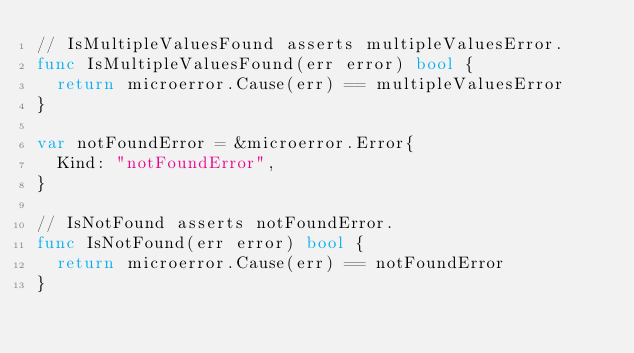Convert code to text. <code><loc_0><loc_0><loc_500><loc_500><_Go_>// IsMultipleValuesFound asserts multipleValuesError.
func IsMultipleValuesFound(err error) bool {
	return microerror.Cause(err) == multipleValuesError
}

var notFoundError = &microerror.Error{
	Kind: "notFoundError",
}

// IsNotFound asserts notFoundError.
func IsNotFound(err error) bool {
	return microerror.Cause(err) == notFoundError
}
</code> 